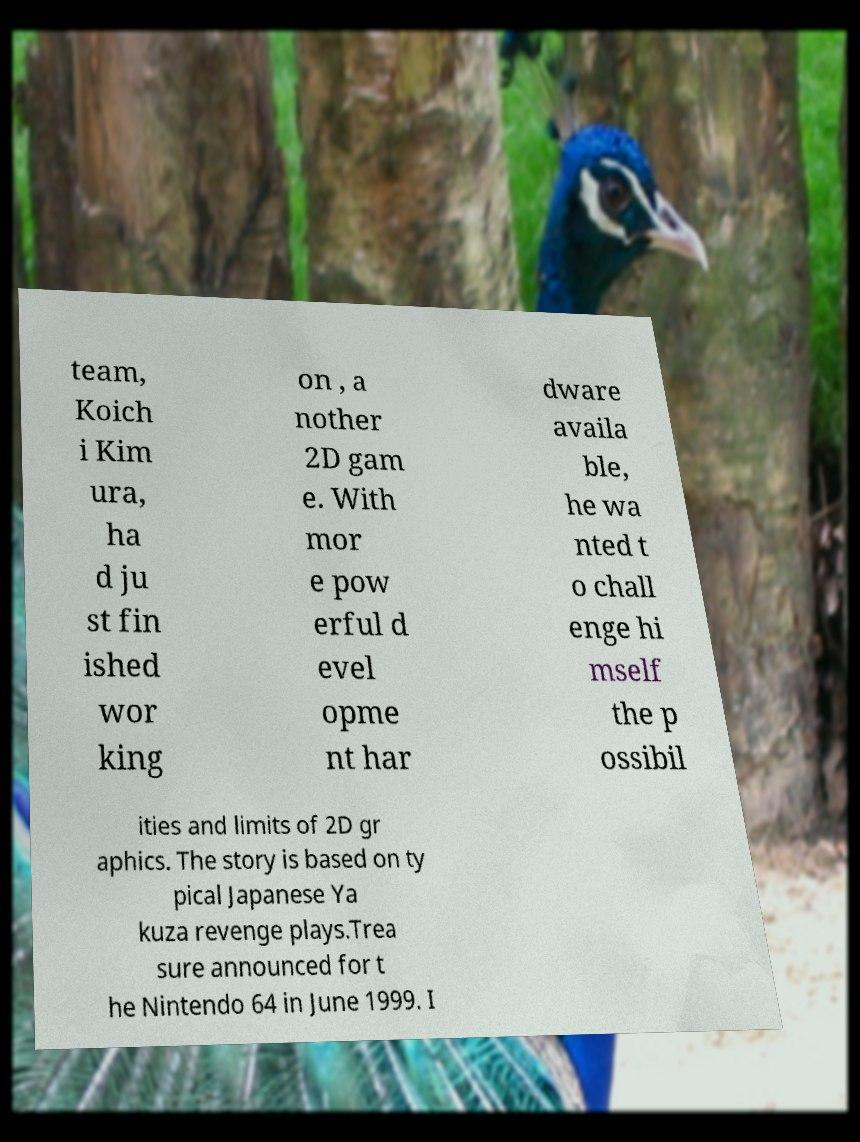There's text embedded in this image that I need extracted. Can you transcribe it verbatim? team, Koich i Kim ura, ha d ju st fin ished wor king on , a nother 2D gam e. With mor e pow erful d evel opme nt har dware availa ble, he wa nted t o chall enge hi mself the p ossibil ities and limits of 2D gr aphics. The story is based on ty pical Japanese Ya kuza revenge plays.Trea sure announced for t he Nintendo 64 in June 1999. I 